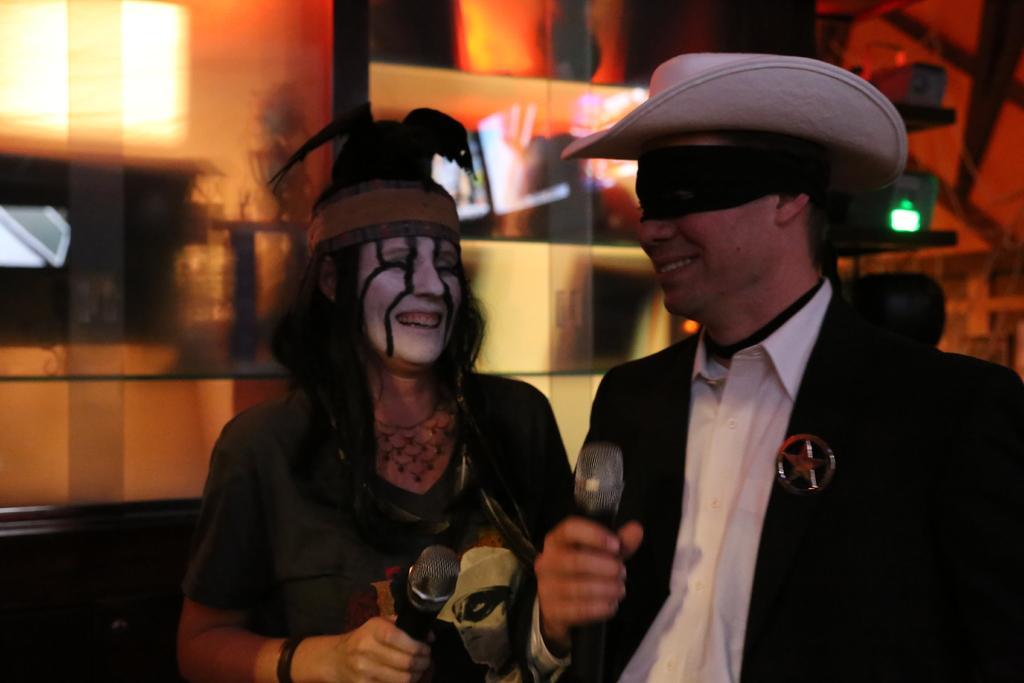Can you describe this image briefly? This is the picture of a place where we have a lady who has some painting on her face and she is holding the mic and also we can see a guy wearing suit and behind there are some lights. 